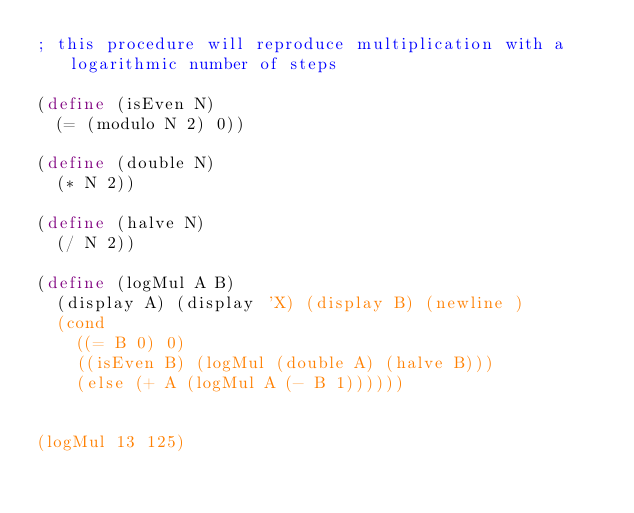Convert code to text. <code><loc_0><loc_0><loc_500><loc_500><_Scheme_>; this procedure will reproduce multiplication with a logarithmic number of steps

(define (isEven N)
  (= (modulo N 2) 0))

(define (double N)
  (* N 2))

(define (halve N)
  (/ N 2))

(define (logMul A B)
  (display A) (display 'X) (display B) (newline )
  (cond
    ((= B 0) 0)
    ((isEven B) (logMul (double A) (halve B)))
    (else (+ A (logMul A (- B 1))))))


(logMul 13 125)
</code> 